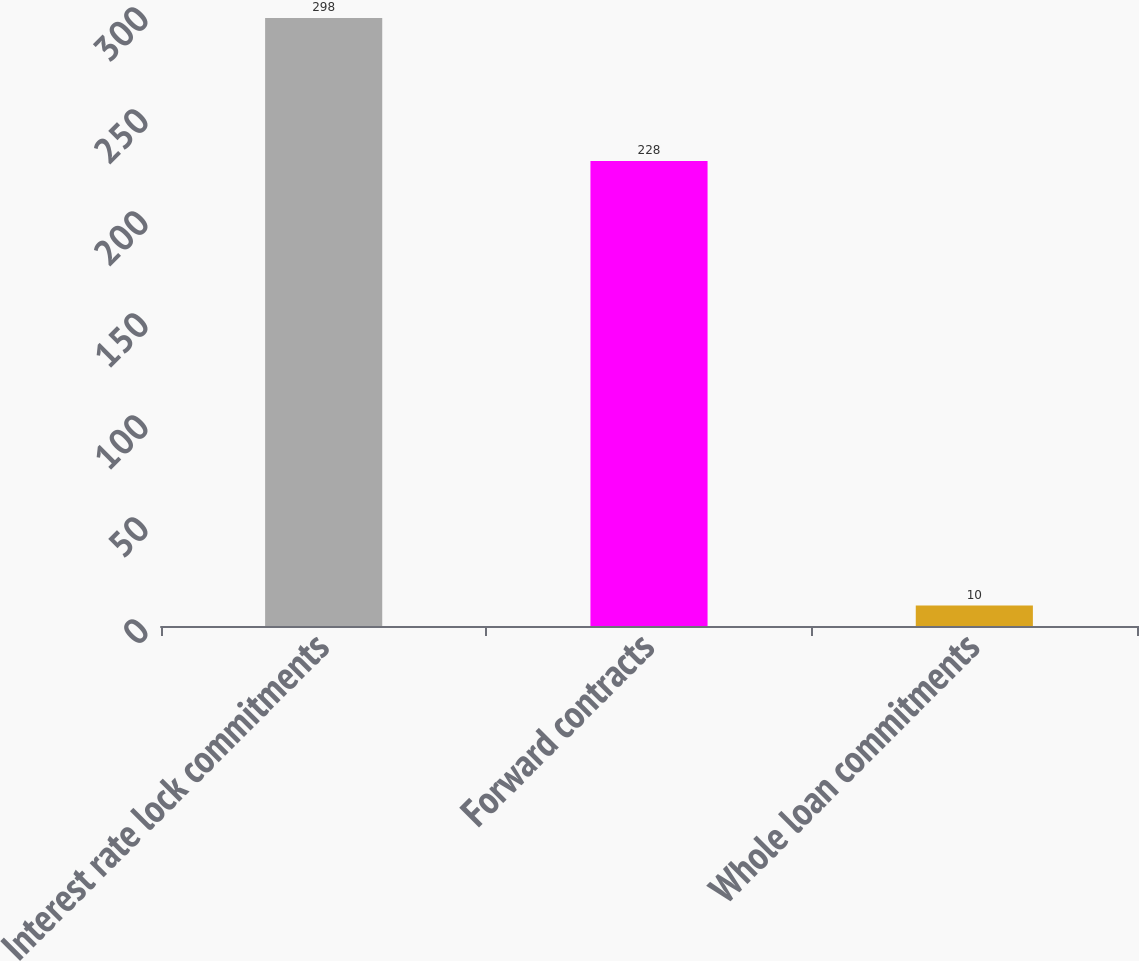Convert chart. <chart><loc_0><loc_0><loc_500><loc_500><bar_chart><fcel>Interest rate lock commitments<fcel>Forward contracts<fcel>Whole loan commitments<nl><fcel>298<fcel>228<fcel>10<nl></chart> 